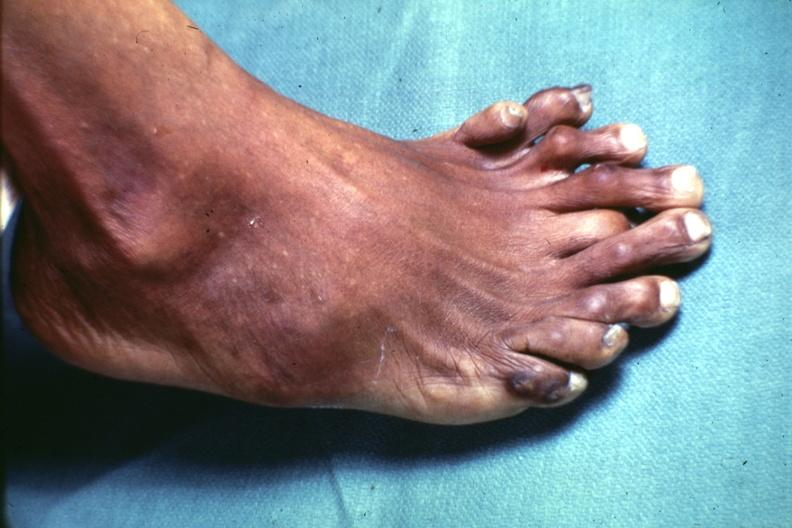re extremities present?
Answer the question using a single word or phrase. Yes 